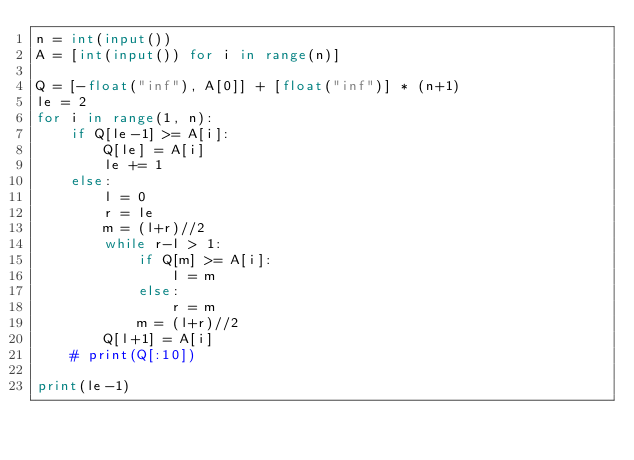<code> <loc_0><loc_0><loc_500><loc_500><_Python_>n = int(input())
A = [int(input()) for i in range(n)]

Q = [-float("inf"), A[0]] + [float("inf")] * (n+1)
le = 2
for i in range(1, n):
    if Q[le-1] >= A[i]:
        Q[le] = A[i]
        le += 1
    else:
        l = 0
        r = le
        m = (l+r)//2
        while r-l > 1:
            if Q[m] >= A[i]:
                l = m
            else:
                r = m
            m = (l+r)//2
        Q[l+1] = A[i]
    # print(Q[:10])

print(le-1)</code> 